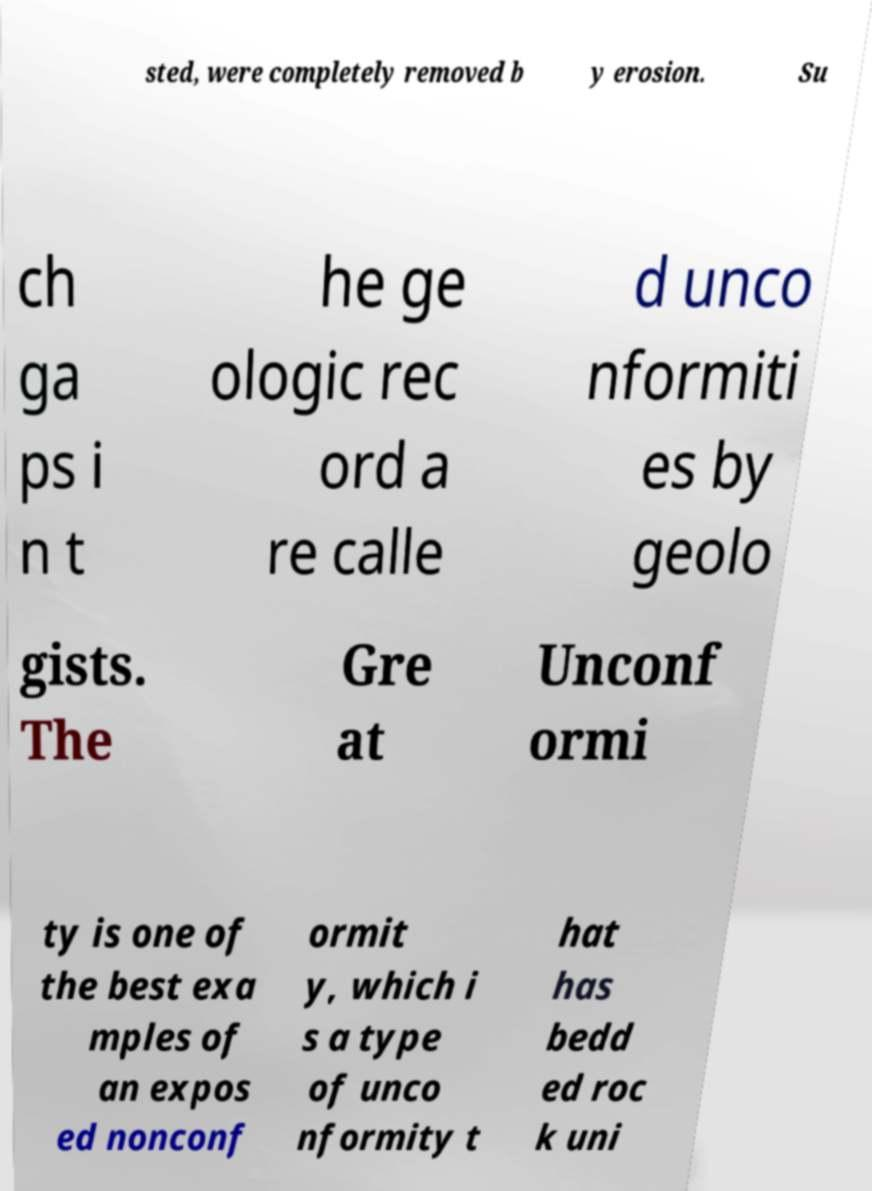Please read and relay the text visible in this image. What does it say? sted, were completely removed b y erosion. Su ch ga ps i n t he ge ologic rec ord a re calle d unco nformiti es by geolo gists. The Gre at Unconf ormi ty is one of the best exa mples of an expos ed nonconf ormit y, which i s a type of unco nformity t hat has bedd ed roc k uni 